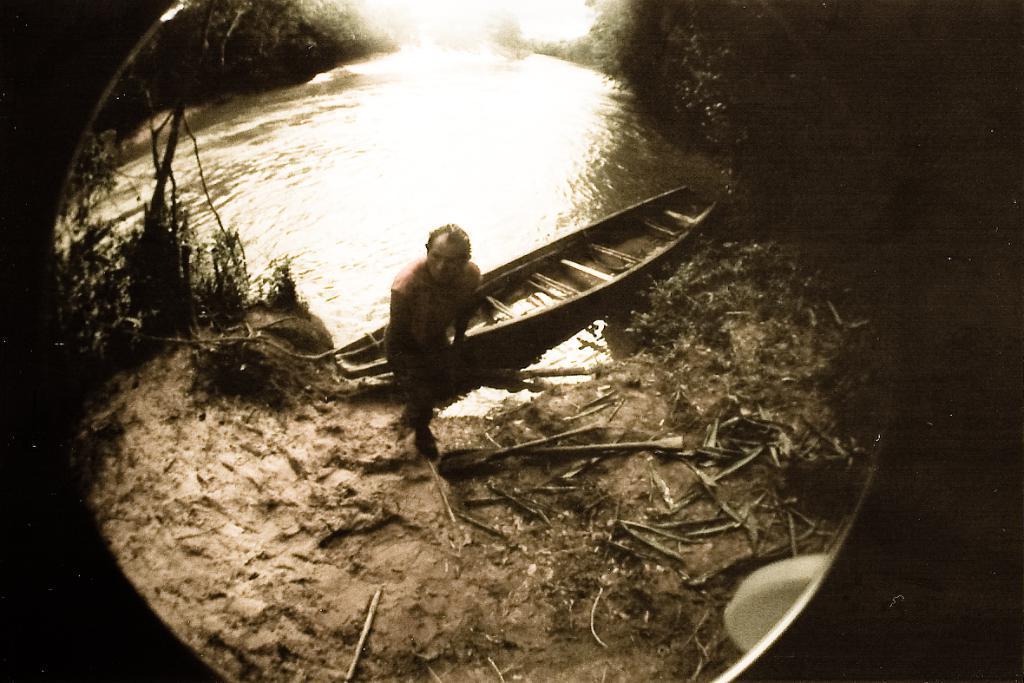How would you summarize this image in a sentence or two? In this image we can see river, boat, person standing on the ground and trees. 